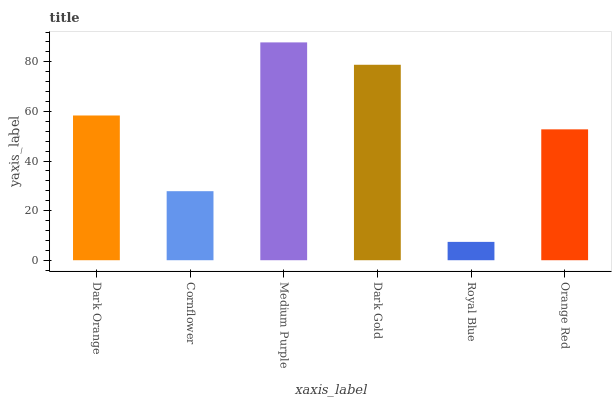Is Royal Blue the minimum?
Answer yes or no. Yes. Is Medium Purple the maximum?
Answer yes or no. Yes. Is Cornflower the minimum?
Answer yes or no. No. Is Cornflower the maximum?
Answer yes or no. No. Is Dark Orange greater than Cornflower?
Answer yes or no. Yes. Is Cornflower less than Dark Orange?
Answer yes or no. Yes. Is Cornflower greater than Dark Orange?
Answer yes or no. No. Is Dark Orange less than Cornflower?
Answer yes or no. No. Is Dark Orange the high median?
Answer yes or no. Yes. Is Orange Red the low median?
Answer yes or no. Yes. Is Medium Purple the high median?
Answer yes or no. No. Is Medium Purple the low median?
Answer yes or no. No. 